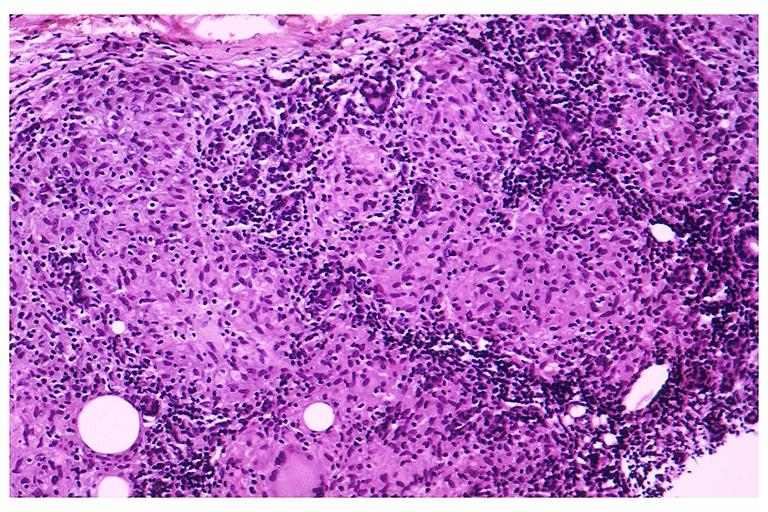s oral present?
Answer the question using a single word or phrase. Yes 